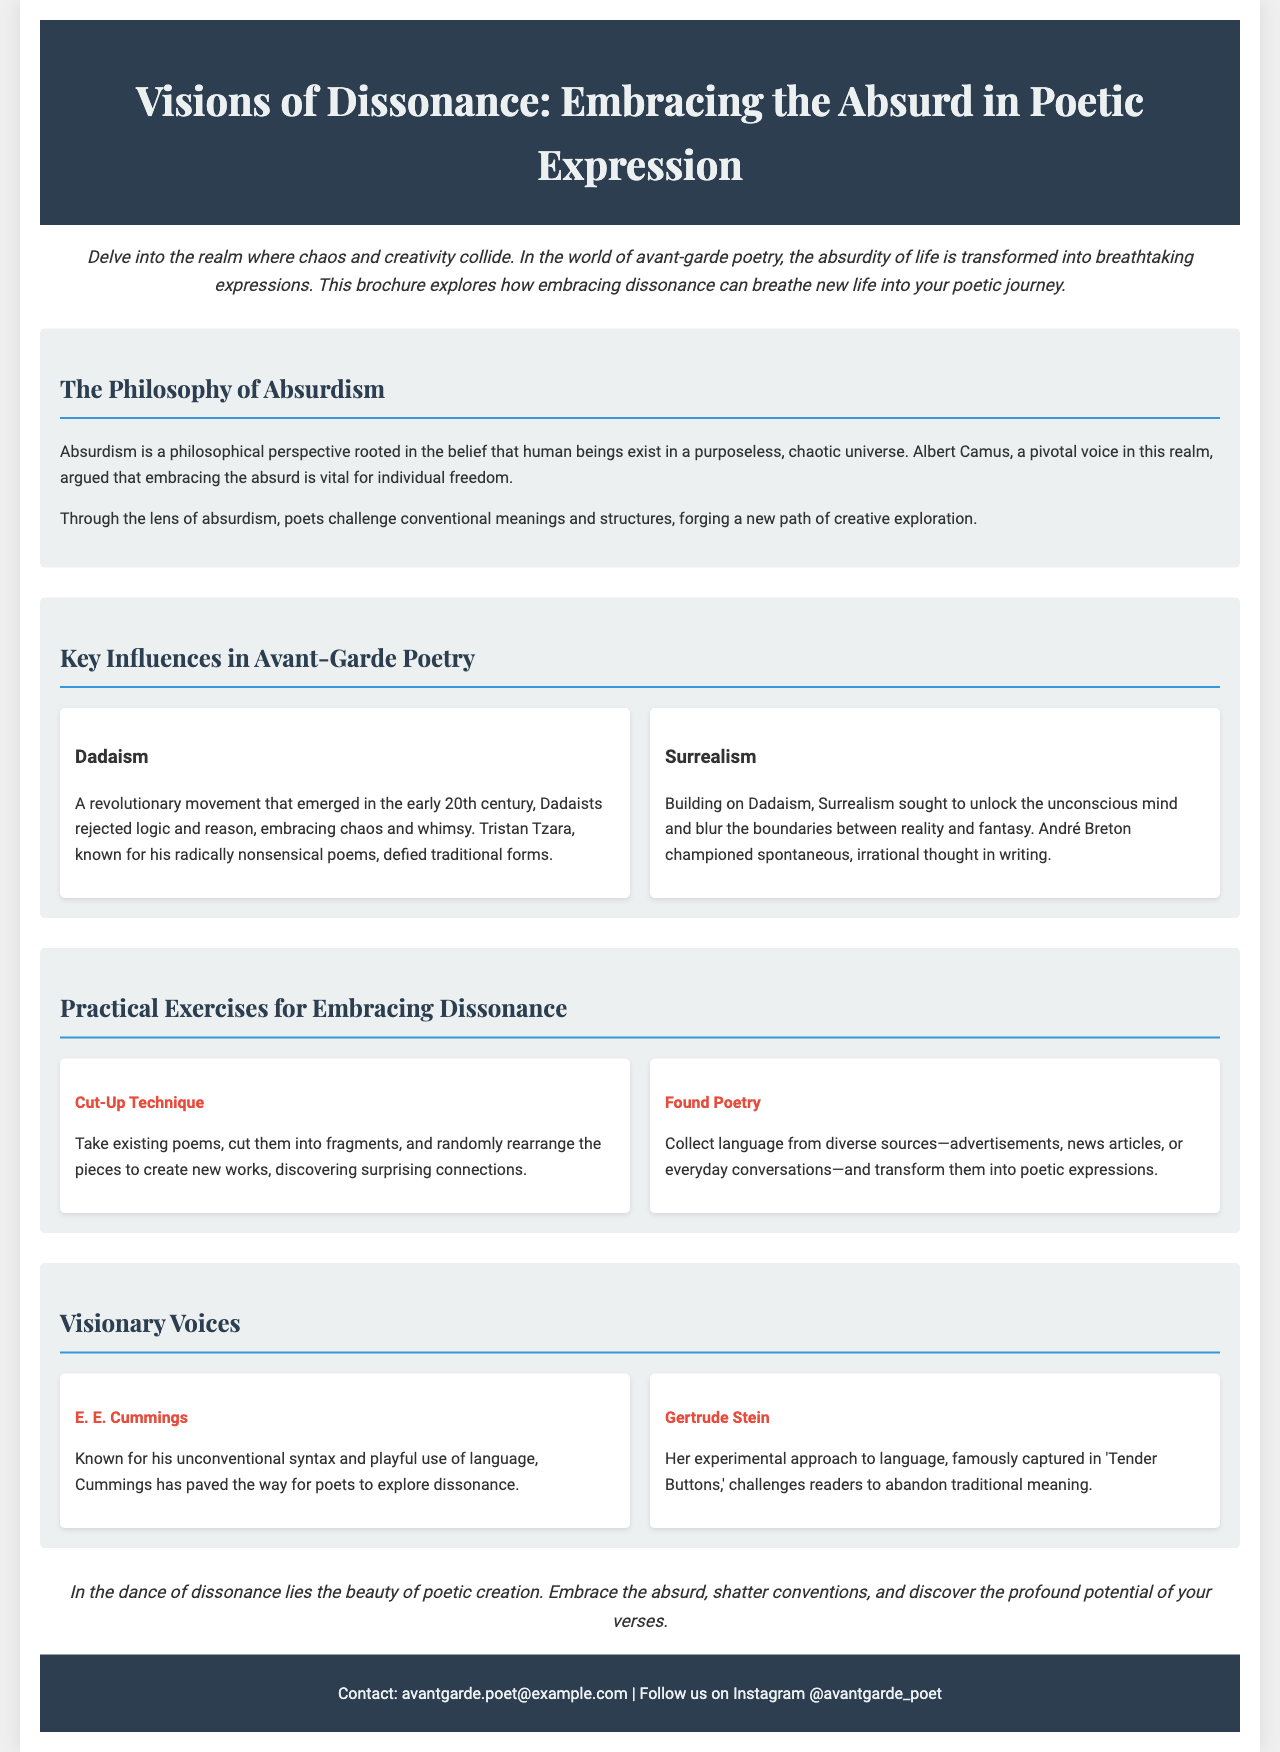What is the title of the brochure? The title is prominently displayed at the top of the document, identifying its subject matter on poetic expression.
Answer: Visions of Dissonance: Embracing the Absurd in Poetic Expression Who is a pivotal voice in the philosophy of absurdism mentioned in the document? This question relates to influential figures discussed in the context of absurdism within the document.
Answer: Albert Camus What are the two main influences in avant-garde poetry listed? The document highlights specific movements in the grid format under key influences.
Answer: Dadaism and Surrealism What technique involves rearranging fragments of existing poems? This is one of the practical exercises mentioned for exploring dissonance in poetry.
Answer: Cut-Up Technique Which poet is known for his unconventional syntax? The section on visionary voices introduces poets known for their distinctive styles, specifically highlighted in the grid.
Answer: E. E. Cummings What type of poetry transforms language from various sources into poetic forms? This question identifies a specific exercise aimed at fostering creativity using found language.
Answer: Found Poetry Which work of Gertrude Stein is mentioned in the brochure? This question draws attention to a key example provided in the context of her literary contributions.
Answer: Tender Buttons What is the main theme of the brochure summarized in the conclusion? The concluding section encapsulates the overarching message of embracing chaos in poetic expression.
Answer: Embrace the absurd 